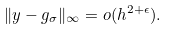<formula> <loc_0><loc_0><loc_500><loc_500>\| y - g _ { \sigma } \| _ { \infty } = { o } ( h ^ { 2 + \epsilon } ) .</formula> 